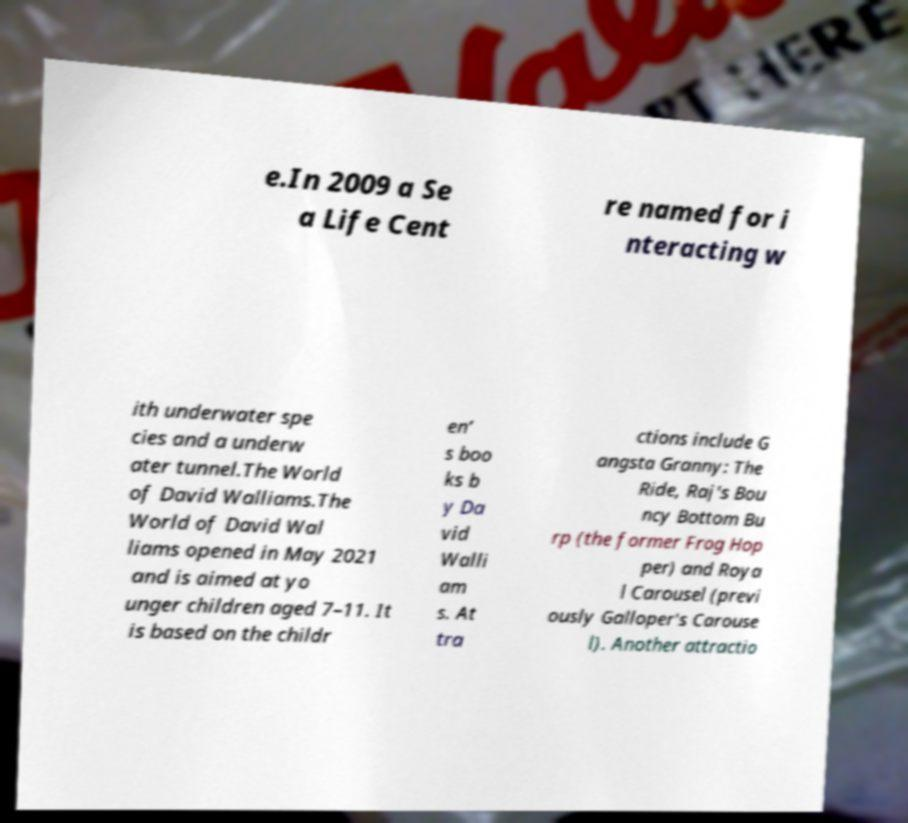Could you assist in decoding the text presented in this image and type it out clearly? e.In 2009 a Se a Life Cent re named for i nteracting w ith underwater spe cies and a underw ater tunnel.The World of David Walliams.The World of David Wal liams opened in May 2021 and is aimed at yo unger children aged 7–11. It is based on the childr en’ s boo ks b y Da vid Walli am s. At tra ctions include G angsta Granny: The Ride, Raj's Bou ncy Bottom Bu rp (the former Frog Hop per) and Roya l Carousel (previ ously Galloper's Carouse l). Another attractio 